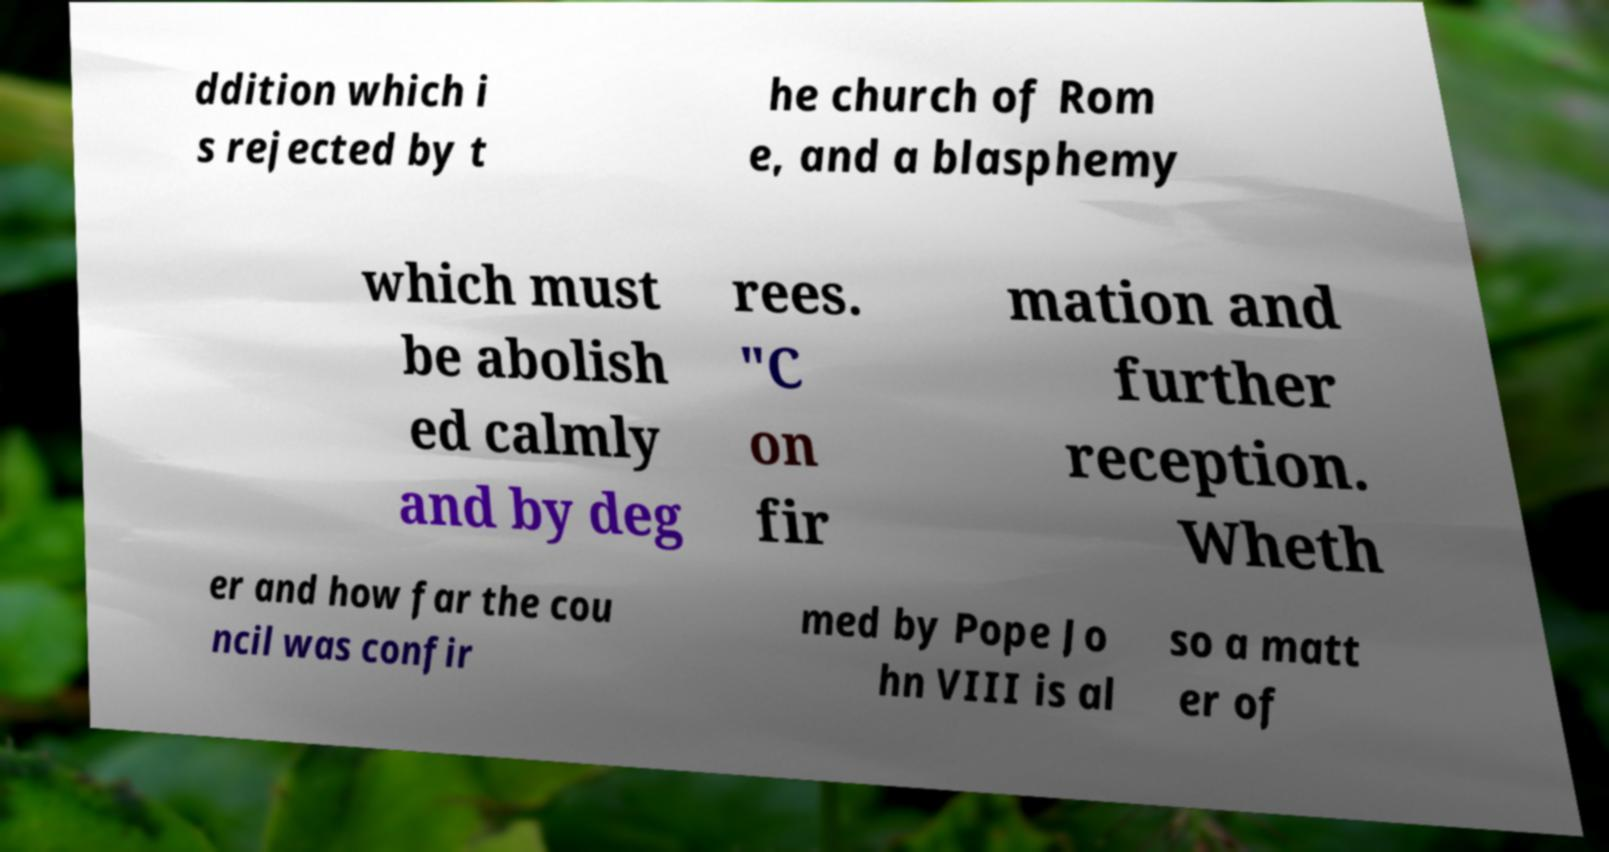Could you assist in decoding the text presented in this image and type it out clearly? ddition which i s rejected by t he church of Rom e, and a blasphemy which must be abolish ed calmly and by deg rees. "C on fir mation and further reception. Wheth er and how far the cou ncil was confir med by Pope Jo hn VIII is al so a matt er of 